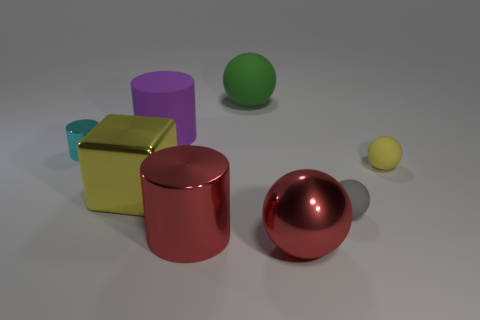Add 2 shiny cylinders. How many objects exist? 10 Subtract all cylinders. How many objects are left? 5 Add 3 purple objects. How many purple objects are left? 4 Add 4 blue cylinders. How many blue cylinders exist? 4 Subtract 0 purple blocks. How many objects are left? 8 Subtract all large blue metallic objects. Subtract all small gray matte objects. How many objects are left? 7 